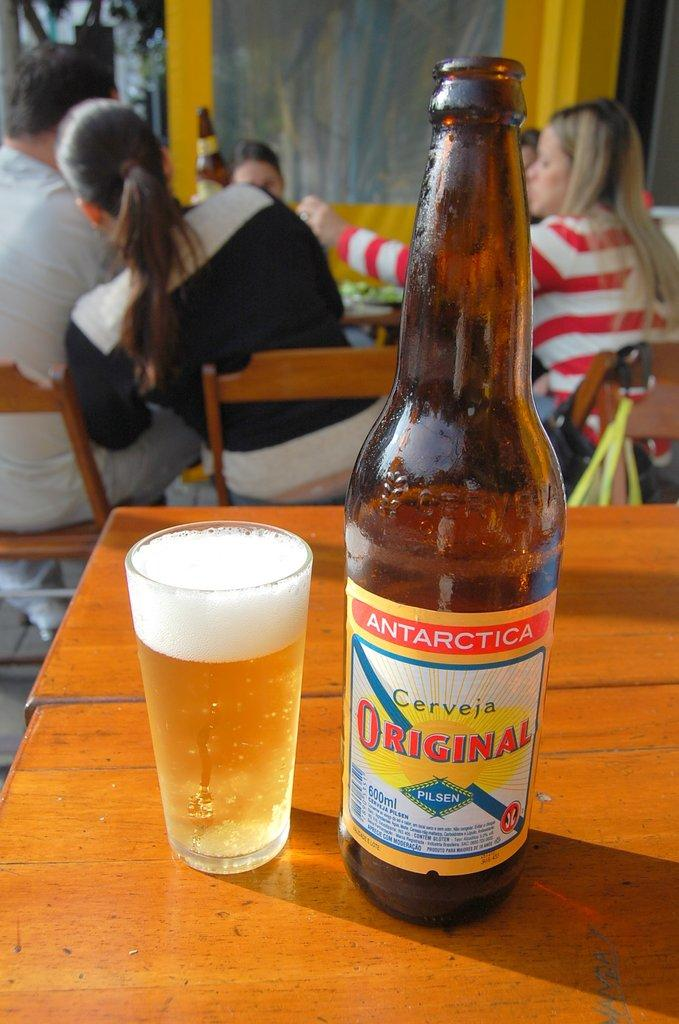<image>
Relay a brief, clear account of the picture shown. Antarctica beer Cerveja original with a blue square with Pilsen in white letters 